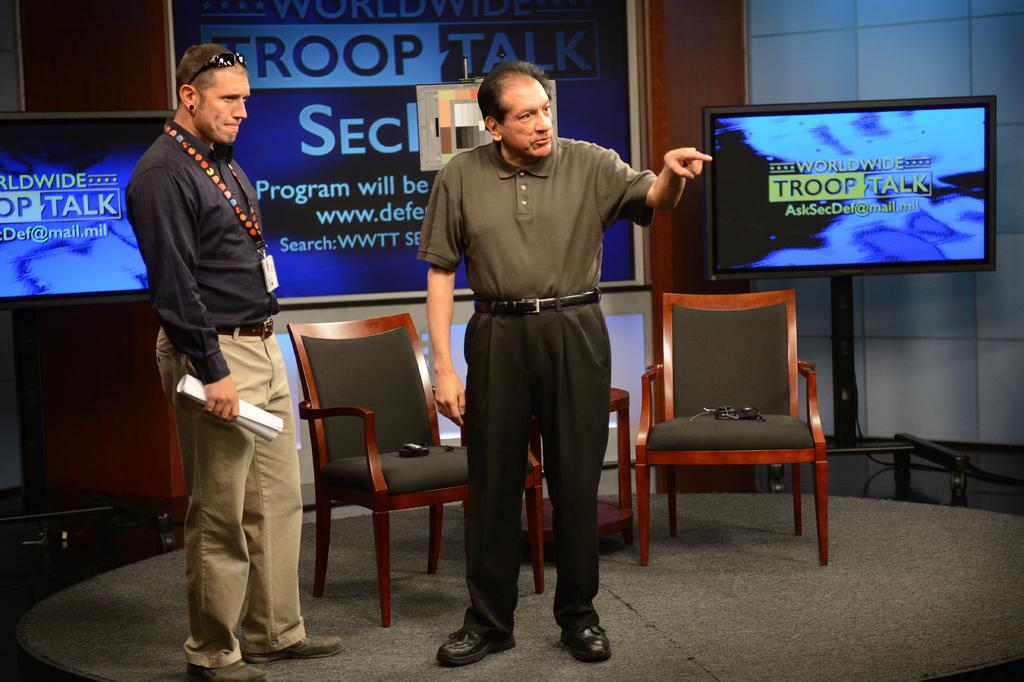How many people are present in the image? There are two men standing in the image. What can be seen in the background of the image? There are chairs and a screen in the background of the image. What type of breakfast is being served on the edge of the screen in the image? There is no breakfast or edge of a screen present in the image. 